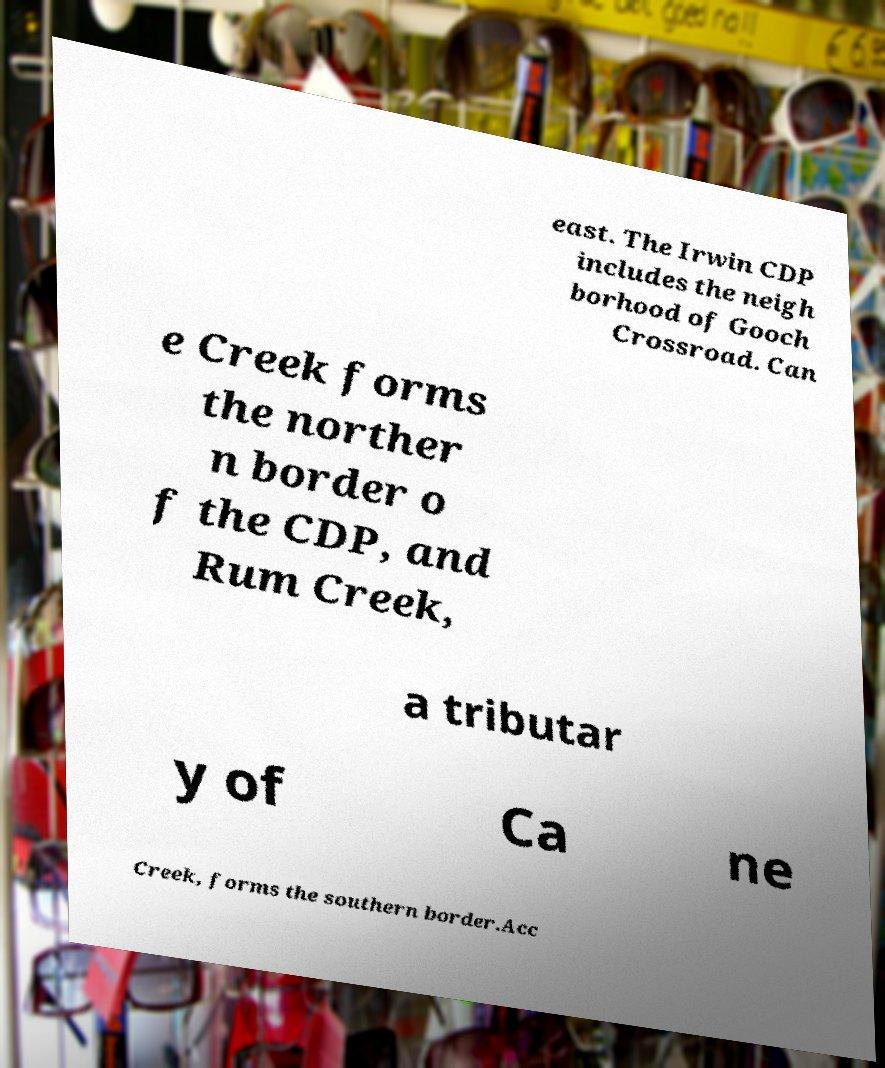For documentation purposes, I need the text within this image transcribed. Could you provide that? east. The Irwin CDP includes the neigh borhood of Gooch Crossroad. Can e Creek forms the norther n border o f the CDP, and Rum Creek, a tributar y of Ca ne Creek, forms the southern border.Acc 